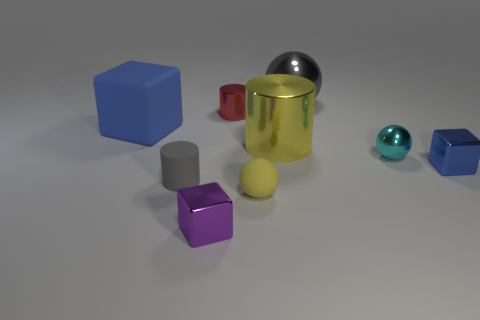Add 1 brown rubber blocks. How many objects exist? 10 Subtract all blocks. How many objects are left? 6 Subtract 0 green cubes. How many objects are left? 9 Subtract all large brown cylinders. Subtract all gray metal objects. How many objects are left? 8 Add 3 tiny cyan spheres. How many tiny cyan spheres are left? 4 Add 1 large yellow objects. How many large yellow objects exist? 2 